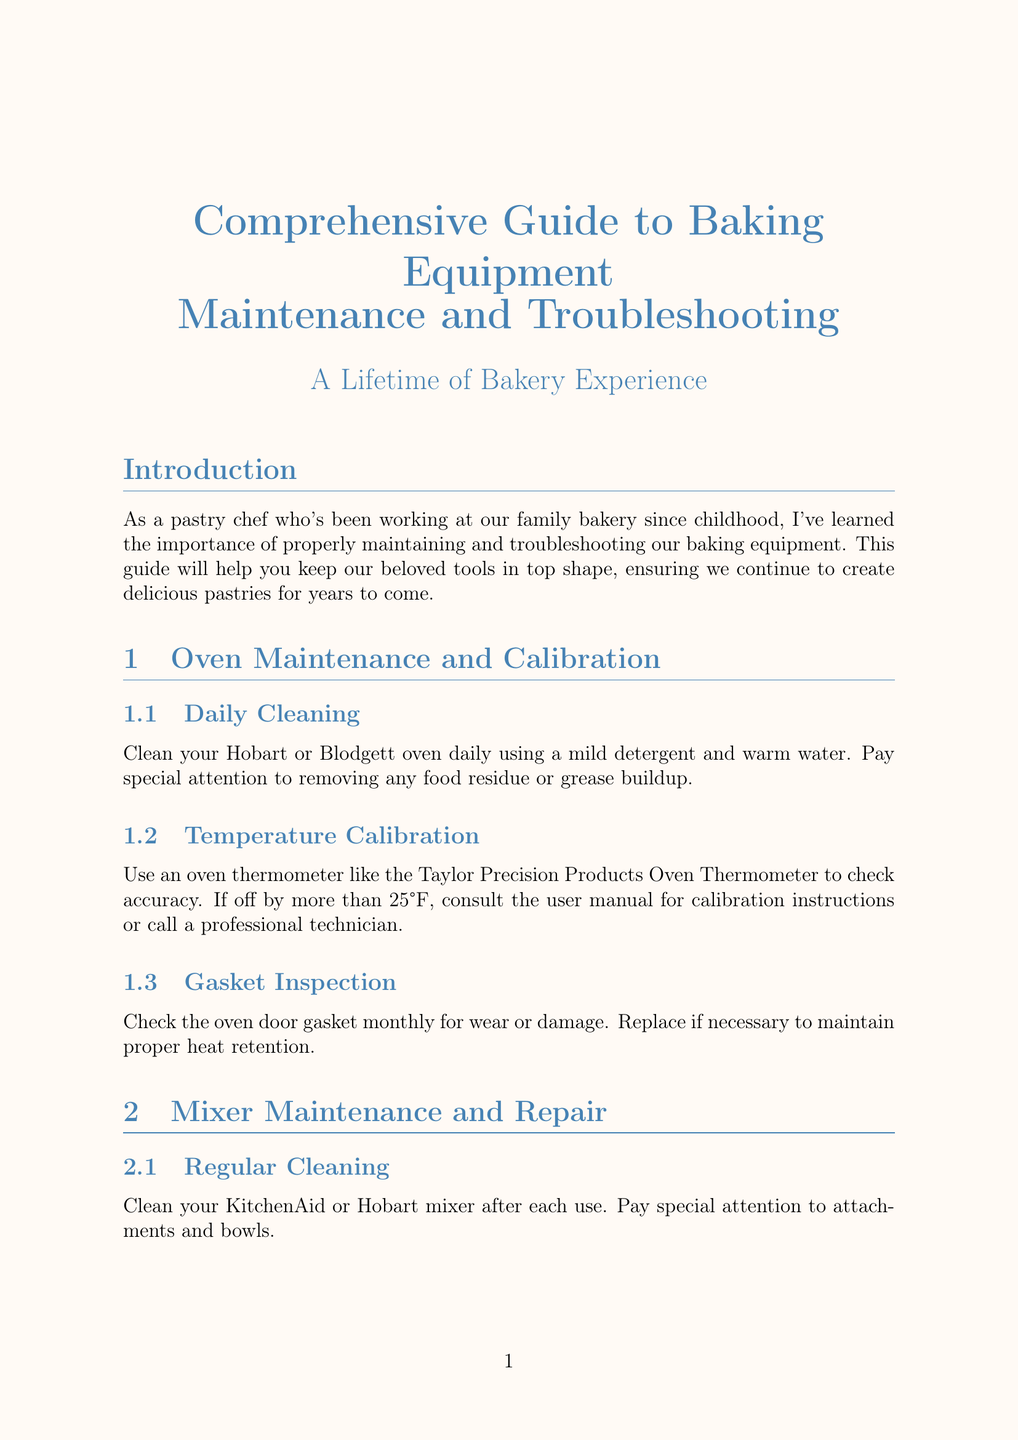What is the focus of this guide? The guide focuses on properly maintaining and troubleshooting baking equipment in a bakery setting, ensuring tools remain in top shape.
Answer: Maintaining and troubleshooting baking equipment How often should the oven gasket be inspected? The document states that the oven door gasket should be checked monthly for wear or damage.
Answer: Monthly What is the recommended thermometer for oven calibration? The guide suggests using the Taylor Precision Products Oven Thermometer to check oven temperature accuracy.
Answer: Taylor Precision Products Oven Thermometer What is one common issue with mixers mentioned in the guide? The guide lists several common issues, one being the mixer won't start, which suggests checking power connection and circuit breaker.
Answer: Mixer won't start How often should refrigerator temperatures be monitored? Daily temperature monitoring is advised for refrigerator and freezer using a reliable thermometer.
Answer: Daily What should be done if the mixer makes strange noises? If there are strange noises coming from the mixer, the guide suggests tightening loose parts or replacing worn gears.
Answer: Tighten loose parts or replace worn gears What maintenance task is advised for food processors? The document recommends regularly sharpening blades of the Cuisinart food processor and lubricating the central shaft annually.
Answer: Sharpen blades and lubricate When should a professional be called for equipment issues? The guide advises consulting a certified technician for major repairs or electrical issues to ensure safety.
Answer: Major repairs or electrical issues What maintenance schedule is suggested for tracking equipment care? A maintenance calendar should be created to track regular cleaning, inspections, and professional servicing for all equipment.
Answer: Maintenance calendar 